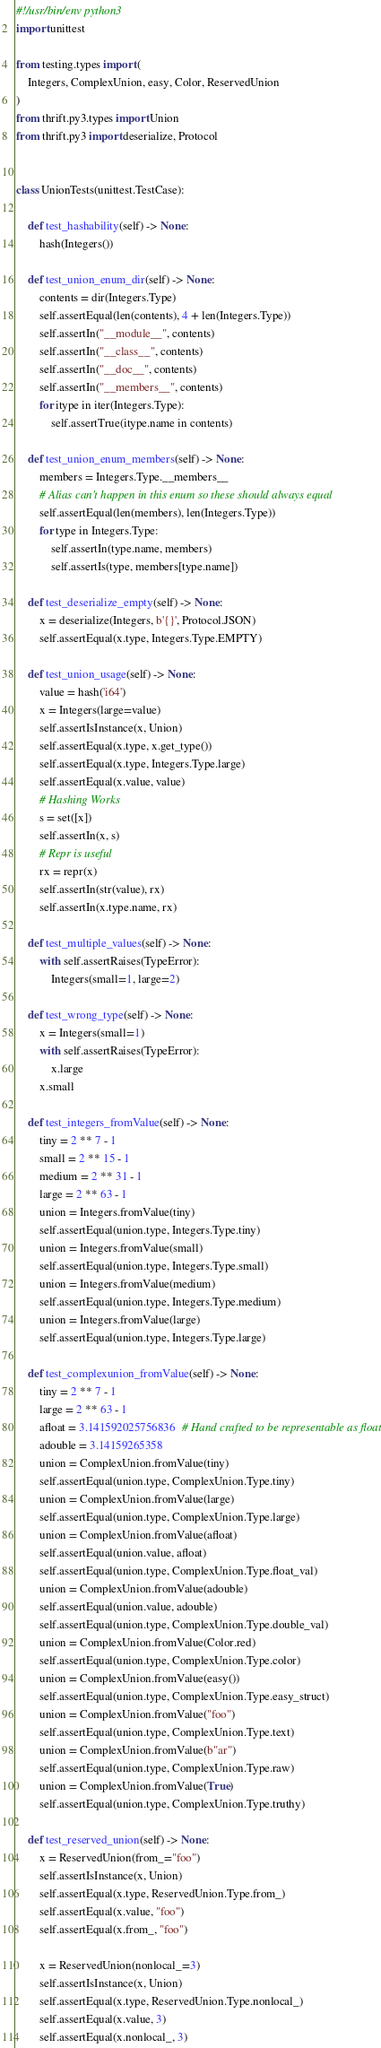Convert code to text. <code><loc_0><loc_0><loc_500><loc_500><_Python_>#!/usr/bin/env python3
import unittest

from testing.types import (
    Integers, ComplexUnion, easy, Color, ReservedUnion
)
from thrift.py3.types import Union
from thrift.py3 import deserialize, Protocol


class UnionTests(unittest.TestCase):

    def test_hashability(self) -> None:
        hash(Integers())

    def test_union_enum_dir(self) -> None:
        contents = dir(Integers.Type)
        self.assertEqual(len(contents), 4 + len(Integers.Type))
        self.assertIn("__module__", contents)
        self.assertIn("__class__", contents)
        self.assertIn("__doc__", contents)
        self.assertIn("__members__", contents)
        for itype in iter(Integers.Type):
            self.assertTrue(itype.name in contents)

    def test_union_enum_members(self) -> None:
        members = Integers.Type.__members__
        # Alias can't happen in this enum so these should always equal
        self.assertEqual(len(members), len(Integers.Type))
        for type in Integers.Type:
            self.assertIn(type.name, members)
            self.assertIs(type, members[type.name])

    def test_deserialize_empty(self) -> None:
        x = deserialize(Integers, b'{}', Protocol.JSON)
        self.assertEqual(x.type, Integers.Type.EMPTY)

    def test_union_usage(self) -> None:
        value = hash('i64')
        x = Integers(large=value)
        self.assertIsInstance(x, Union)
        self.assertEqual(x.type, x.get_type())
        self.assertEqual(x.type, Integers.Type.large)
        self.assertEqual(x.value, value)
        # Hashing Works
        s = set([x])
        self.assertIn(x, s)
        # Repr is useful
        rx = repr(x)
        self.assertIn(str(value), rx)
        self.assertIn(x.type.name, rx)

    def test_multiple_values(self) -> None:
        with self.assertRaises(TypeError):
            Integers(small=1, large=2)

    def test_wrong_type(self) -> None:
        x = Integers(small=1)
        with self.assertRaises(TypeError):
            x.large
        x.small

    def test_integers_fromValue(self) -> None:
        tiny = 2 ** 7 - 1
        small = 2 ** 15 - 1
        medium = 2 ** 31 - 1
        large = 2 ** 63 - 1
        union = Integers.fromValue(tiny)
        self.assertEqual(union.type, Integers.Type.tiny)
        union = Integers.fromValue(small)
        self.assertEqual(union.type, Integers.Type.small)
        union = Integers.fromValue(medium)
        self.assertEqual(union.type, Integers.Type.medium)
        union = Integers.fromValue(large)
        self.assertEqual(union.type, Integers.Type.large)

    def test_complexunion_fromValue(self) -> None:
        tiny = 2 ** 7 - 1
        large = 2 ** 63 - 1
        afloat = 3.141592025756836  # Hand crafted to be representable as float
        adouble = 3.14159265358
        union = ComplexUnion.fromValue(tiny)
        self.assertEqual(union.type, ComplexUnion.Type.tiny)
        union = ComplexUnion.fromValue(large)
        self.assertEqual(union.type, ComplexUnion.Type.large)
        union = ComplexUnion.fromValue(afloat)
        self.assertEqual(union.value, afloat)
        self.assertEqual(union.type, ComplexUnion.Type.float_val)
        union = ComplexUnion.fromValue(adouble)
        self.assertEqual(union.value, adouble)
        self.assertEqual(union.type, ComplexUnion.Type.double_val)
        union = ComplexUnion.fromValue(Color.red)
        self.assertEqual(union.type, ComplexUnion.Type.color)
        union = ComplexUnion.fromValue(easy())
        self.assertEqual(union.type, ComplexUnion.Type.easy_struct)
        union = ComplexUnion.fromValue("foo")
        self.assertEqual(union.type, ComplexUnion.Type.text)
        union = ComplexUnion.fromValue(b"ar")
        self.assertEqual(union.type, ComplexUnion.Type.raw)
        union = ComplexUnion.fromValue(True)
        self.assertEqual(union.type, ComplexUnion.Type.truthy)

    def test_reserved_union(self) -> None:
        x = ReservedUnion(from_="foo")
        self.assertIsInstance(x, Union)
        self.assertEqual(x.type, ReservedUnion.Type.from_)
        self.assertEqual(x.value, "foo")
        self.assertEqual(x.from_, "foo")

        x = ReservedUnion(nonlocal_=3)
        self.assertIsInstance(x, Union)
        self.assertEqual(x.type, ReservedUnion.Type.nonlocal_)
        self.assertEqual(x.value, 3)
        self.assertEqual(x.nonlocal_, 3)
</code> 